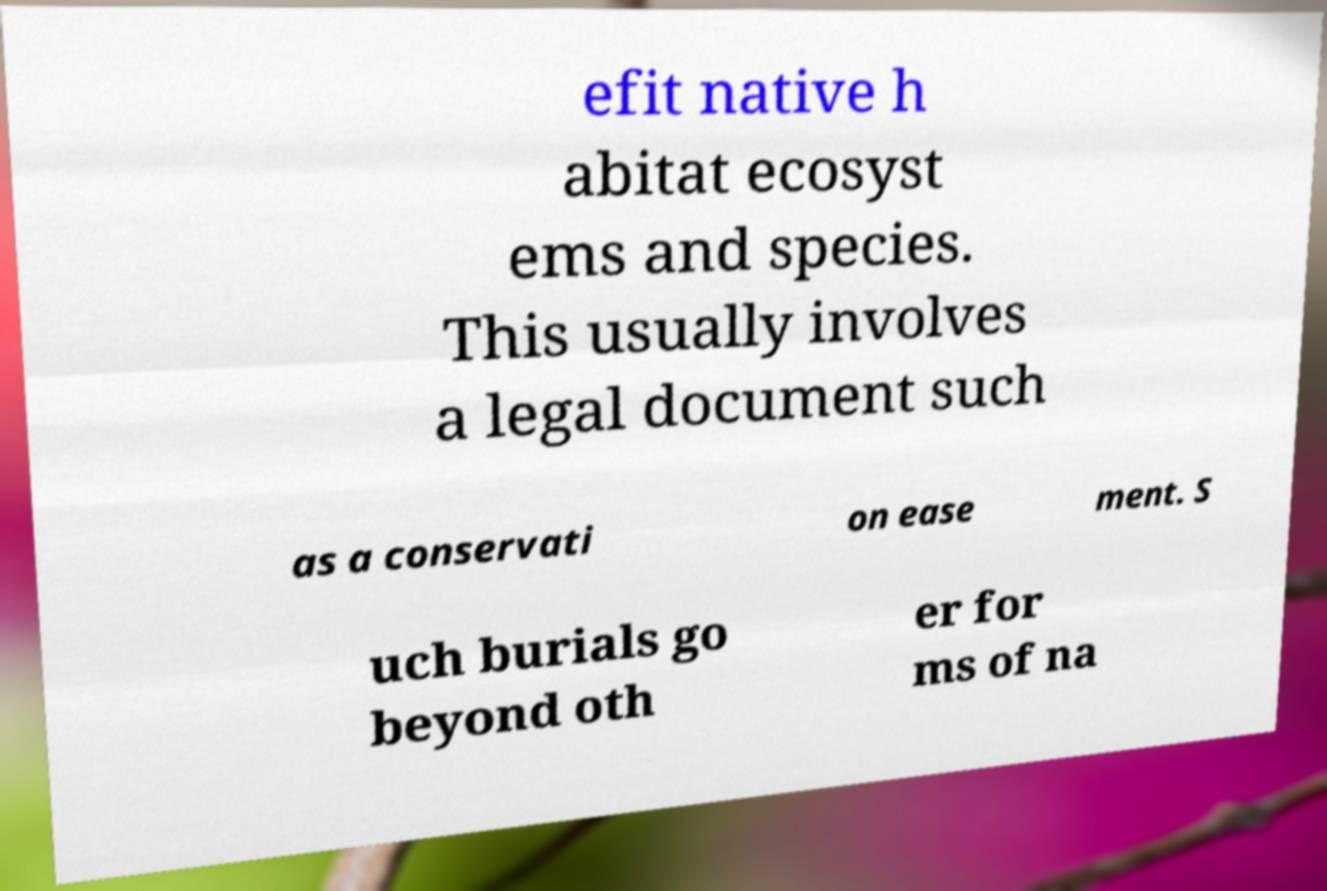For documentation purposes, I need the text within this image transcribed. Could you provide that? efit native h abitat ecosyst ems and species. This usually involves a legal document such as a conservati on ease ment. S uch burials go beyond oth er for ms of na 